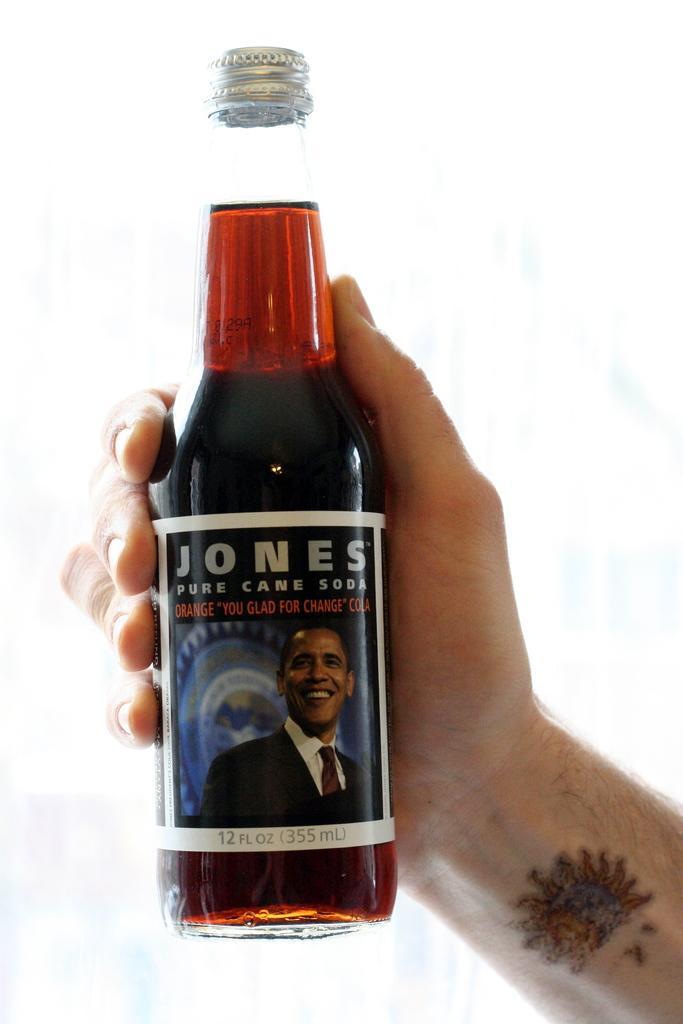Could you give a brief overview of what you see in this image? In this image there is a red color soda bottle which is holding by a man's hand and there is a tattoo for his wrist and the soda bottle has label naming Jones pure cane soda which is of 355ml. 